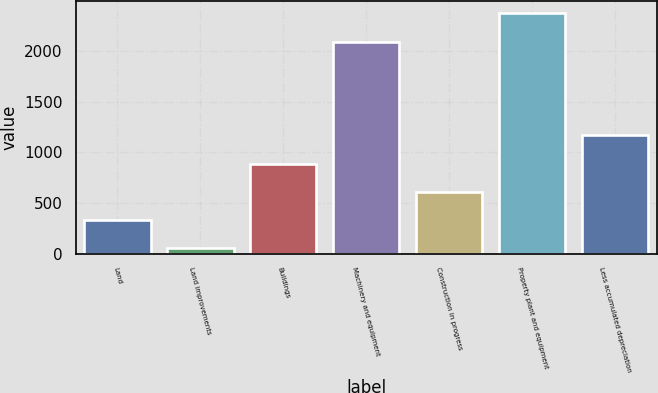Convert chart to OTSL. <chart><loc_0><loc_0><loc_500><loc_500><bar_chart><fcel>Land<fcel>Land improvements<fcel>Buildings<fcel>Machinery and equipment<fcel>Construction in progress<fcel>Property plant and equipment<fcel>Less accumulated depreciation<nl><fcel>330.1<fcel>51<fcel>888.3<fcel>2089<fcel>609.2<fcel>2368.1<fcel>1167.4<nl></chart> 